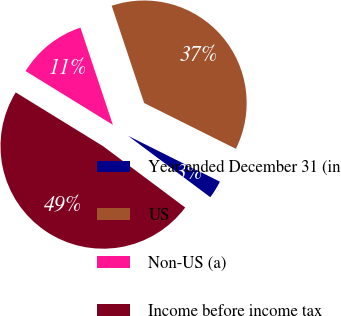Convert chart to OTSL. <chart><loc_0><loc_0><loc_500><loc_500><pie_chart><fcel>Year ended December 31 (in<fcel>US<fcel>Non-US (a)<fcel>Income before income tax<nl><fcel>2.84%<fcel>37.49%<fcel>11.09%<fcel>48.58%<nl></chart> 